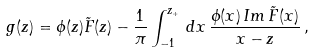<formula> <loc_0><loc_0><loc_500><loc_500>g ( z ) = \phi ( z ) \tilde { F } ( z ) - { \frac { 1 } { \pi } } \int _ { - 1 } ^ { z _ { + } } \, d x \, { \frac { \phi ( x ) \, I m \, \tilde { F } ( x ) } { x - z } } \, ,</formula> 